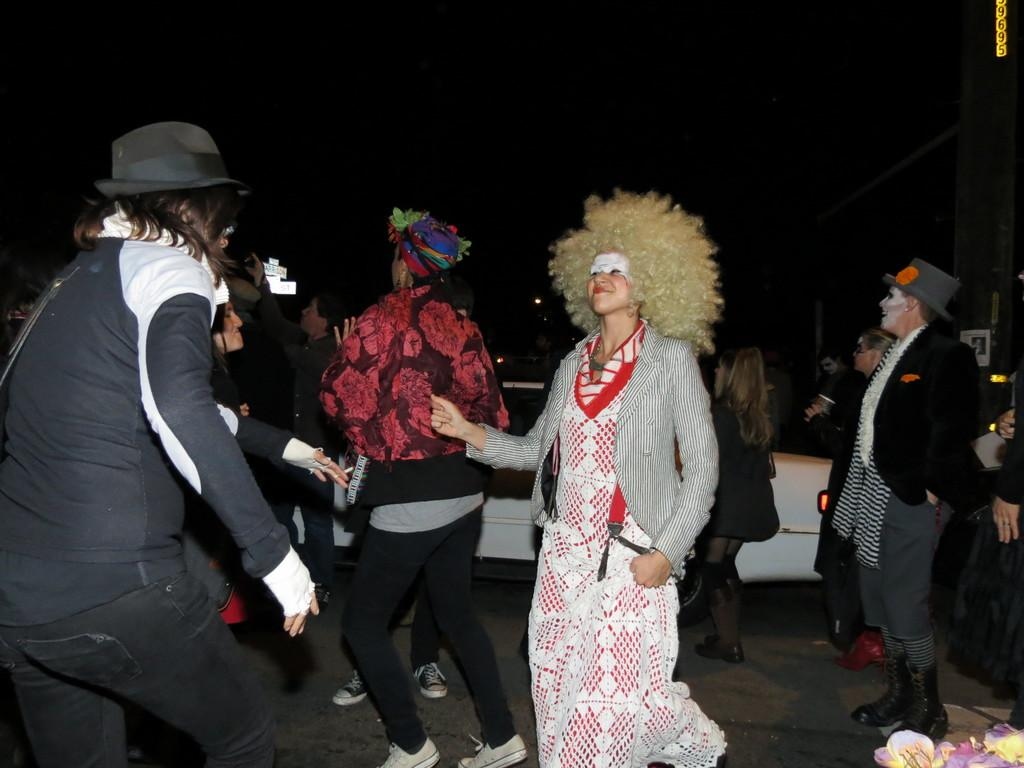What is happening on the surface in the image? There are people on the surface in the image. Can you describe the appearance of some of the people? Some people are wearing costumes. What can be seen in the background of the image? There is a vehicle visible in the background of the image. What type of treatment is being administered to the people in the image? There is no indication in the image that any treatment is being administered to the people. What is the size of the apparatus visible in the image? There is no apparatus present in the image. 